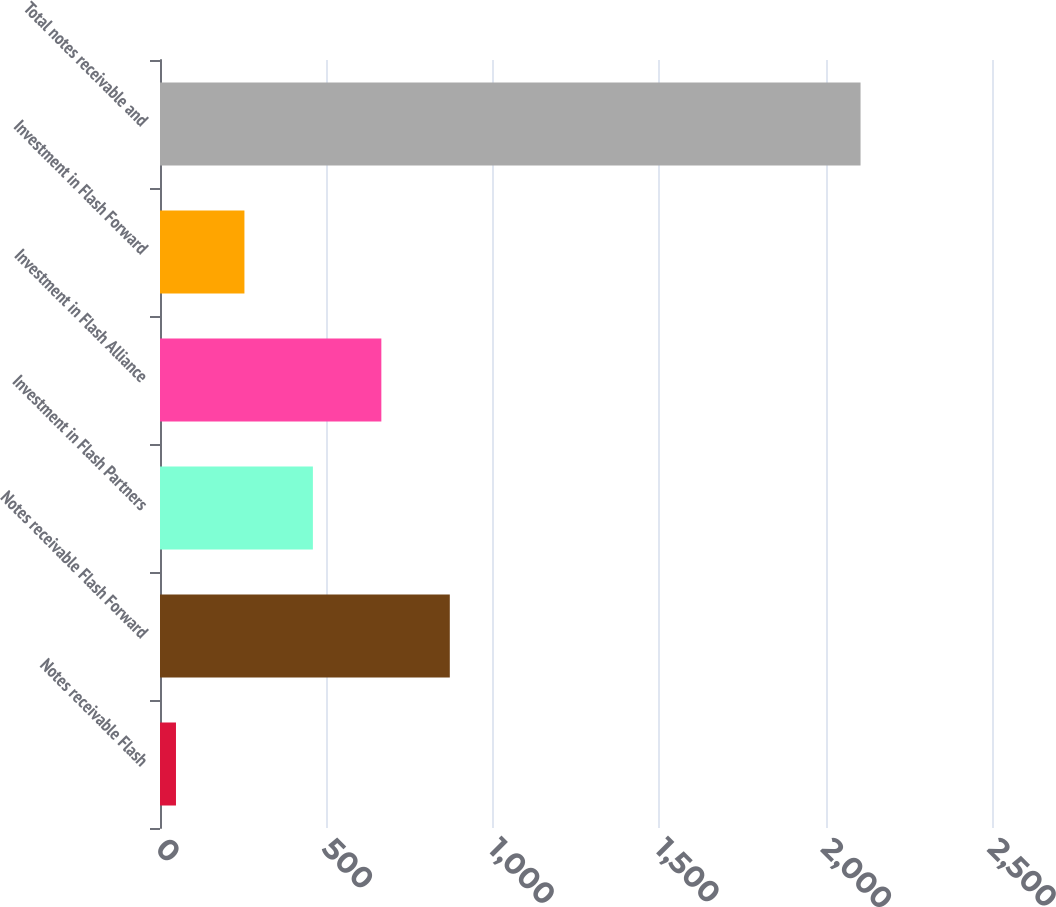<chart> <loc_0><loc_0><loc_500><loc_500><bar_chart><fcel>Notes receivable Flash<fcel>Notes receivable Flash Forward<fcel>Investment in Flash Partners<fcel>Investment in Flash Alliance<fcel>Investment in Flash Forward<fcel>Total notes receivable and<nl><fcel>48<fcel>870.8<fcel>459.4<fcel>665.1<fcel>253.7<fcel>2105<nl></chart> 